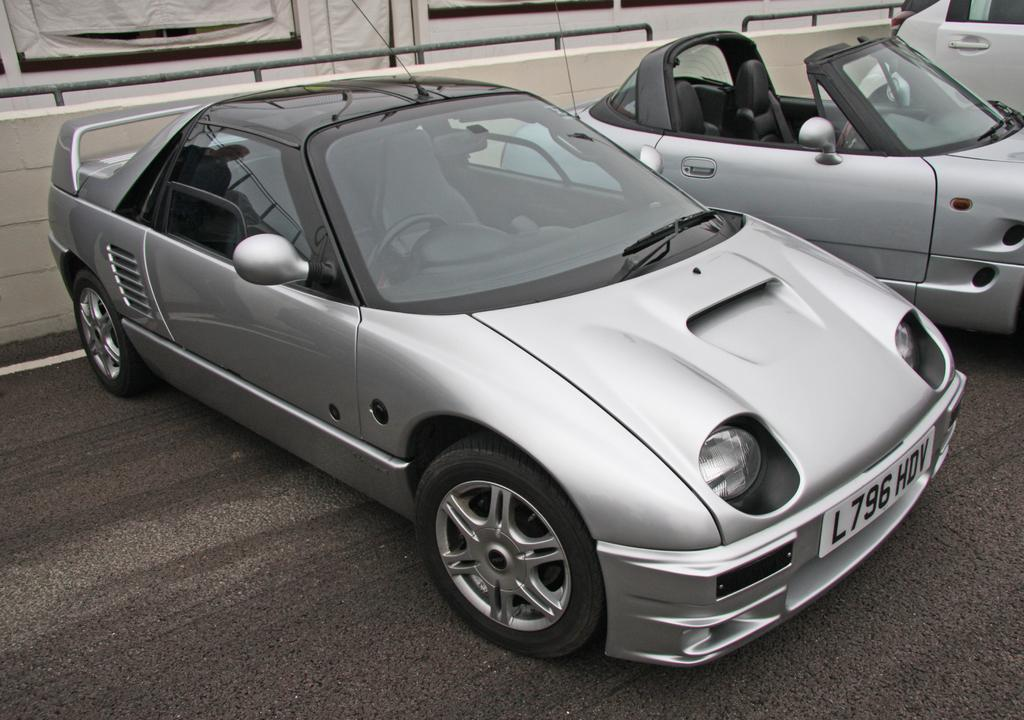How many cars are visible in the image? There are three cars in the image. Where are the cars located in the image? The cars are parked on a path in the image. What is the color of the cars? The cars are gray in color, with some parts being black. What is near the cars in the image? The cars are near a wall in the image. What type of cakes are being served at the car operation near the donkey in the image? There are no cakes, car operation, or donkey present in the image. 